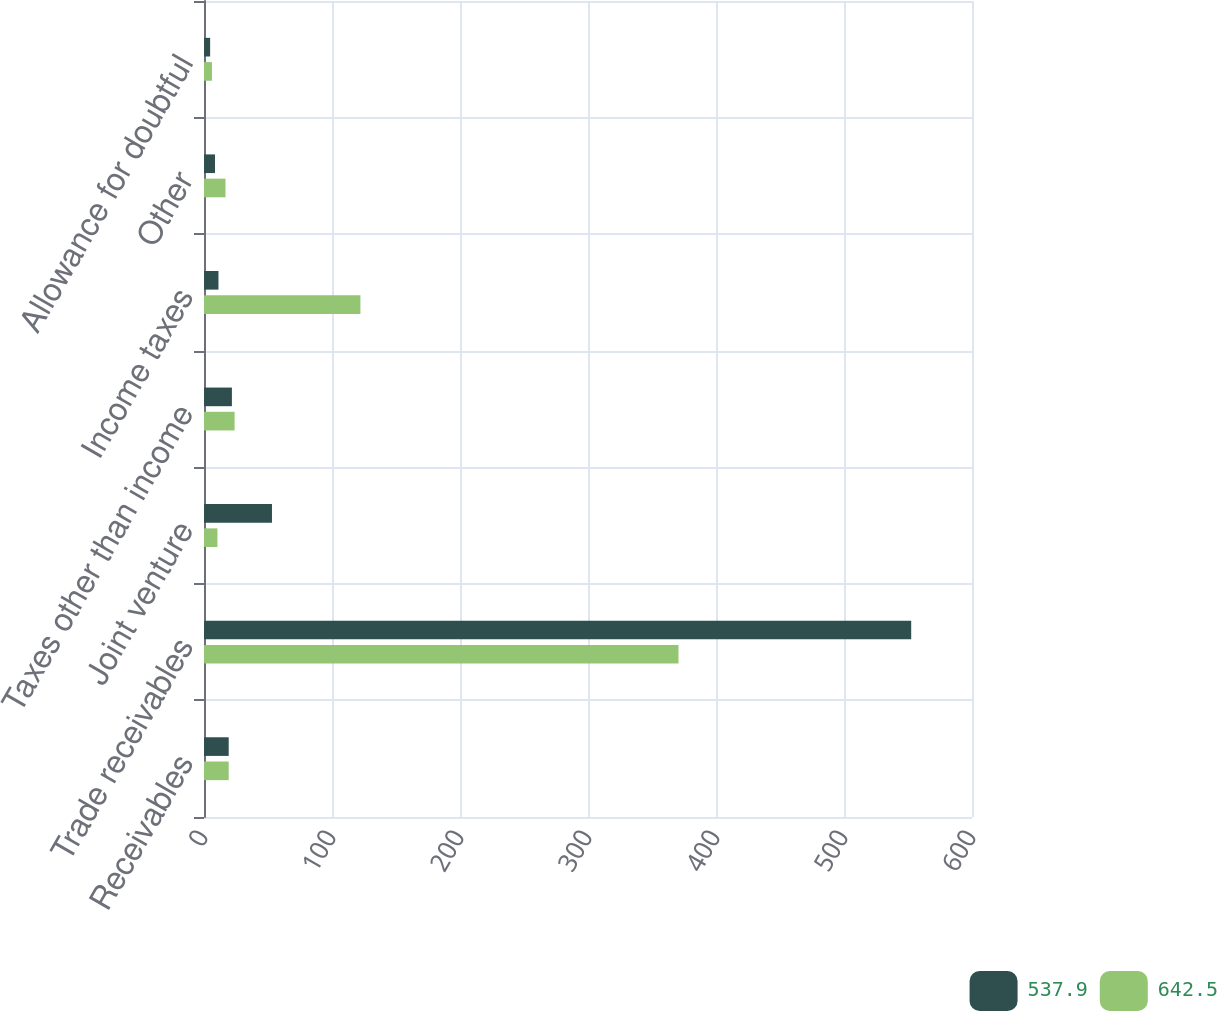<chart> <loc_0><loc_0><loc_500><loc_500><stacked_bar_chart><ecel><fcel>Receivables<fcel>Trade receivables<fcel>Joint venture<fcel>Taxes other than income<fcel>Income taxes<fcel>Other<fcel>Allowance for doubtful<nl><fcel>537.9<fcel>19.3<fcel>552.5<fcel>53.1<fcel>21.8<fcel>11.3<fcel>8.6<fcel>4.8<nl><fcel>642.5<fcel>19.3<fcel>370.7<fcel>10.5<fcel>23.9<fcel>122.2<fcel>16.8<fcel>6.2<nl></chart> 